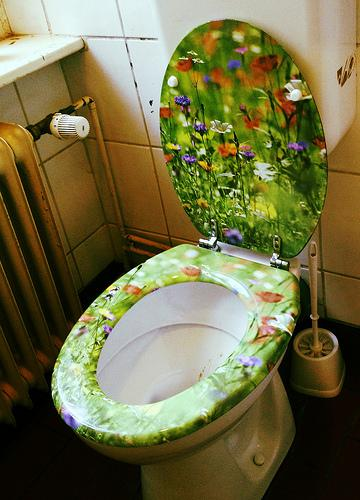Question: where is the photo taken?
Choices:
A. Bedroom.
B. Bathroom.
C. Basement.
D. Living room.
Answer with the letter. Answer: B Question: what is painted?
Choices:
A. Seat and lid.
B. Bowl and top.
C. Floor and trim.
D. Ceiling and walls.
Answer with the letter. Answer: A Question: what shape are the walls tile?
Choices:
A. Octagon.
B. Triangle.
C. Rectangle.
D. Square.
Answer with the letter. Answer: D Question: where is the toilet brush?
Choices:
A. To the right of the toilet.
B. Under the toilet.
C. To the left of the toilet.
D. Behind the toilet.
Answer with the letter. Answer: B 